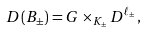<formula> <loc_0><loc_0><loc_500><loc_500>D ( B _ { \pm } ) = G \times _ { K _ { \pm } } D ^ { \ell _ { \pm } } ,</formula> 